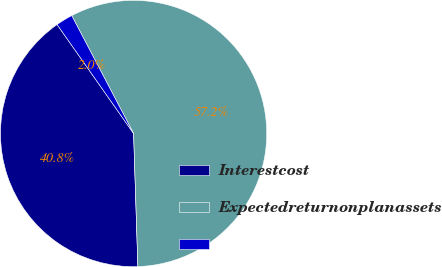<chart> <loc_0><loc_0><loc_500><loc_500><pie_chart><fcel>Interestcost<fcel>Expectedreturnonplanassets<fcel>Unnamed: 2<nl><fcel>40.77%<fcel>57.18%<fcel>2.05%<nl></chart> 